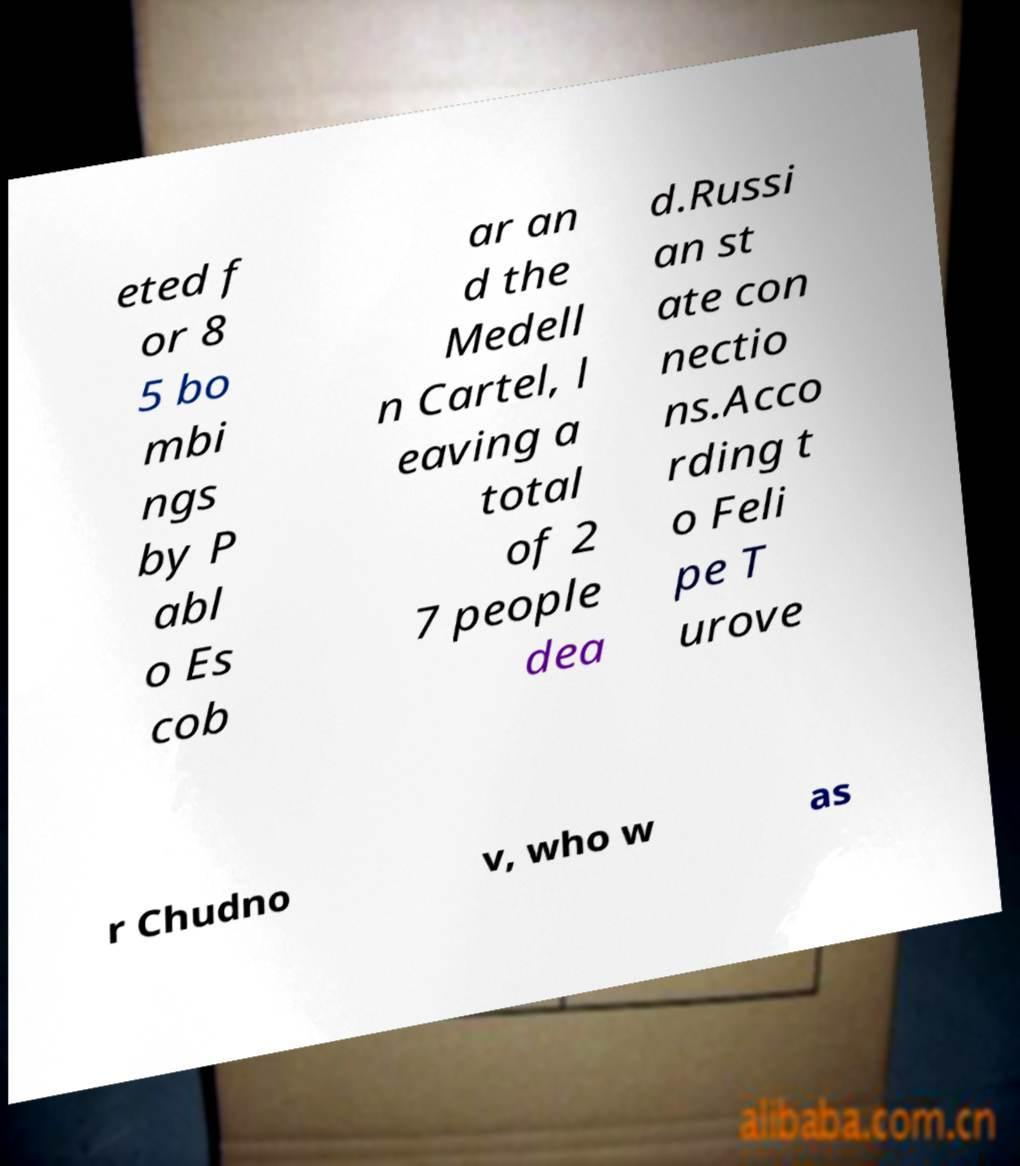Can you accurately transcribe the text from the provided image for me? eted f or 8 5 bo mbi ngs by P abl o Es cob ar an d the Medell n Cartel, l eaving a total of 2 7 people dea d.Russi an st ate con nectio ns.Acco rding t o Feli pe T urove r Chudno v, who w as 